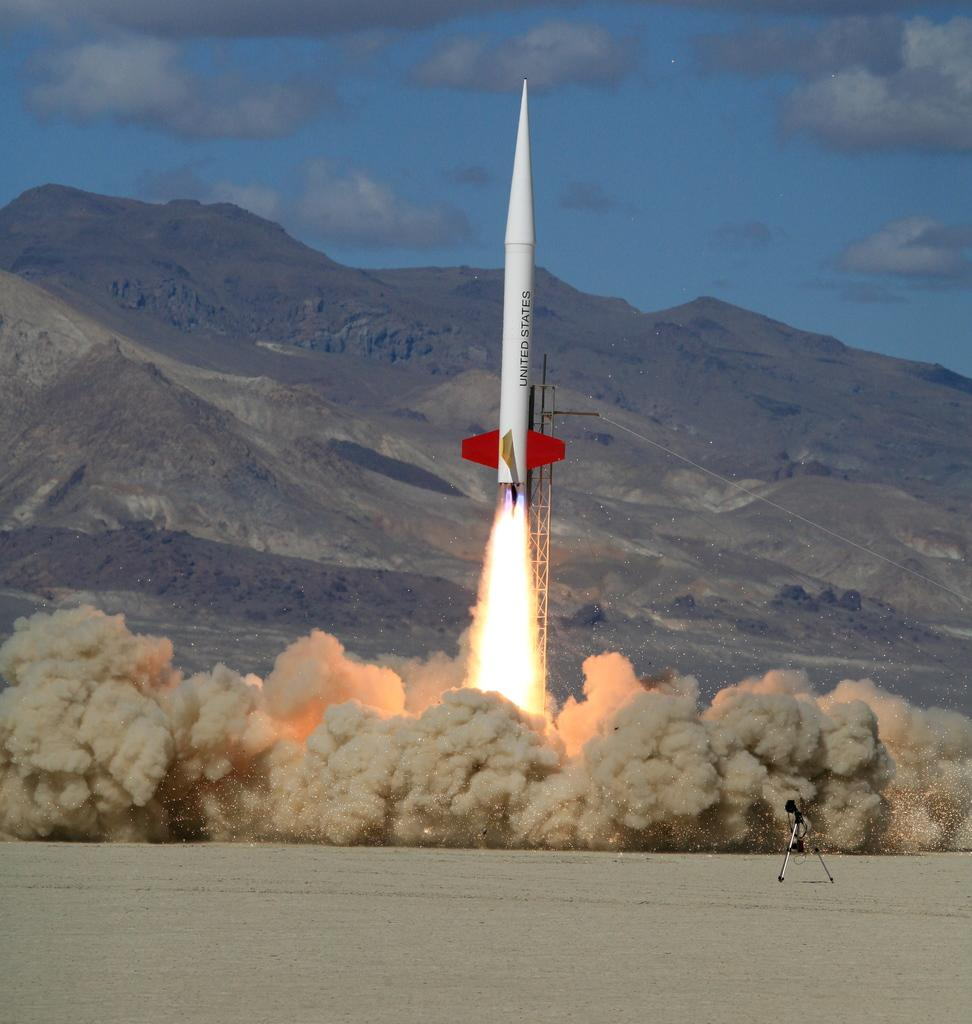<image>
Write a terse but informative summary of the picture. A white rocket with red tails is launching and says UNITED STATES in black lettering 